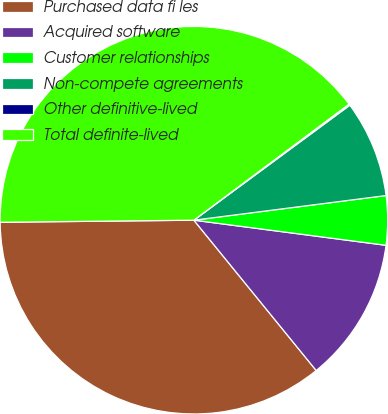<chart> <loc_0><loc_0><loc_500><loc_500><pie_chart><fcel>Purchased data fi les<fcel>Acquired software<fcel>Customer relationships<fcel>Non-compete agreements<fcel>Other definitive-lived<fcel>Total definite-lived<nl><fcel>35.7%<fcel>12.06%<fcel>4.1%<fcel>8.08%<fcel>0.11%<fcel>39.95%<nl></chart> 